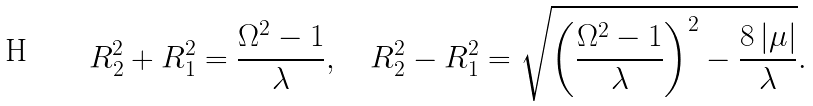<formula> <loc_0><loc_0><loc_500><loc_500>R _ { 2 } ^ { 2 } + R _ { 1 } ^ { 2 } = \frac { \Omega ^ { 2 } - 1 } { \lambda } , \quad R _ { 2 } ^ { 2 } - R _ { 1 } ^ { 2 } = \sqrt { \left ( \frac { \Omega ^ { 2 } - 1 } { \lambda } \right ) ^ { 2 } - \frac { 8 \, | \mu | } { \lambda } } .</formula> 